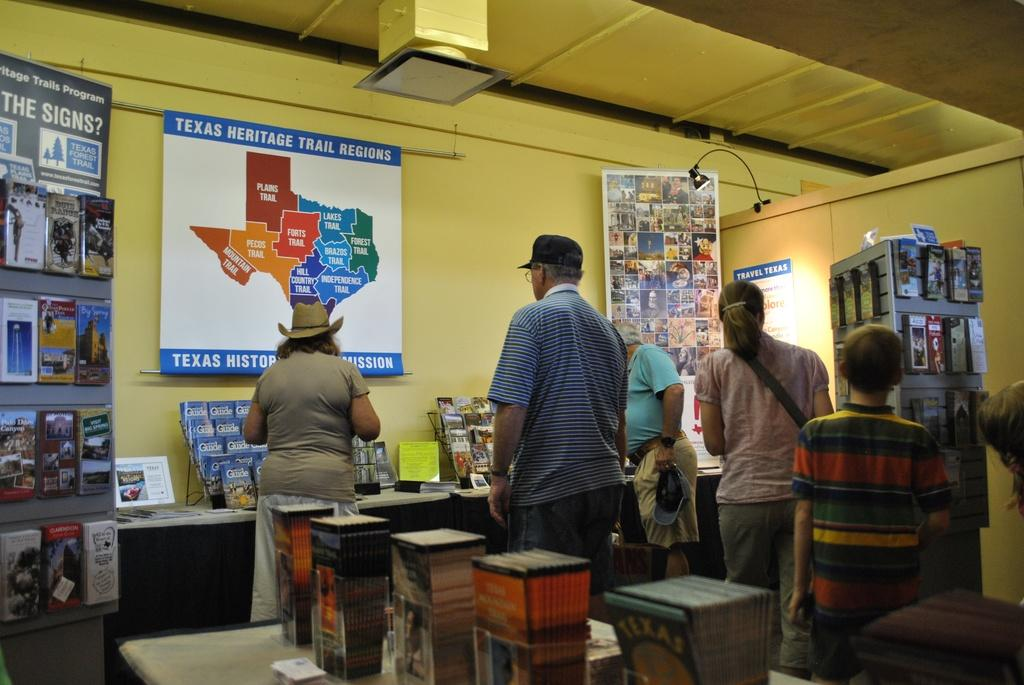What can be seen in the image involving people? There are persons standing in the image. What type of objects are hanging on the wall? There are posters in the image. What is the background of the image made of? There is a wall in the image. What items are related to reading or learning? There are books in the image. What provides illumination in the image? There is a light in the image. What type of pear is being used as a skirt in the image? There is no pear or skirt present in the image. 